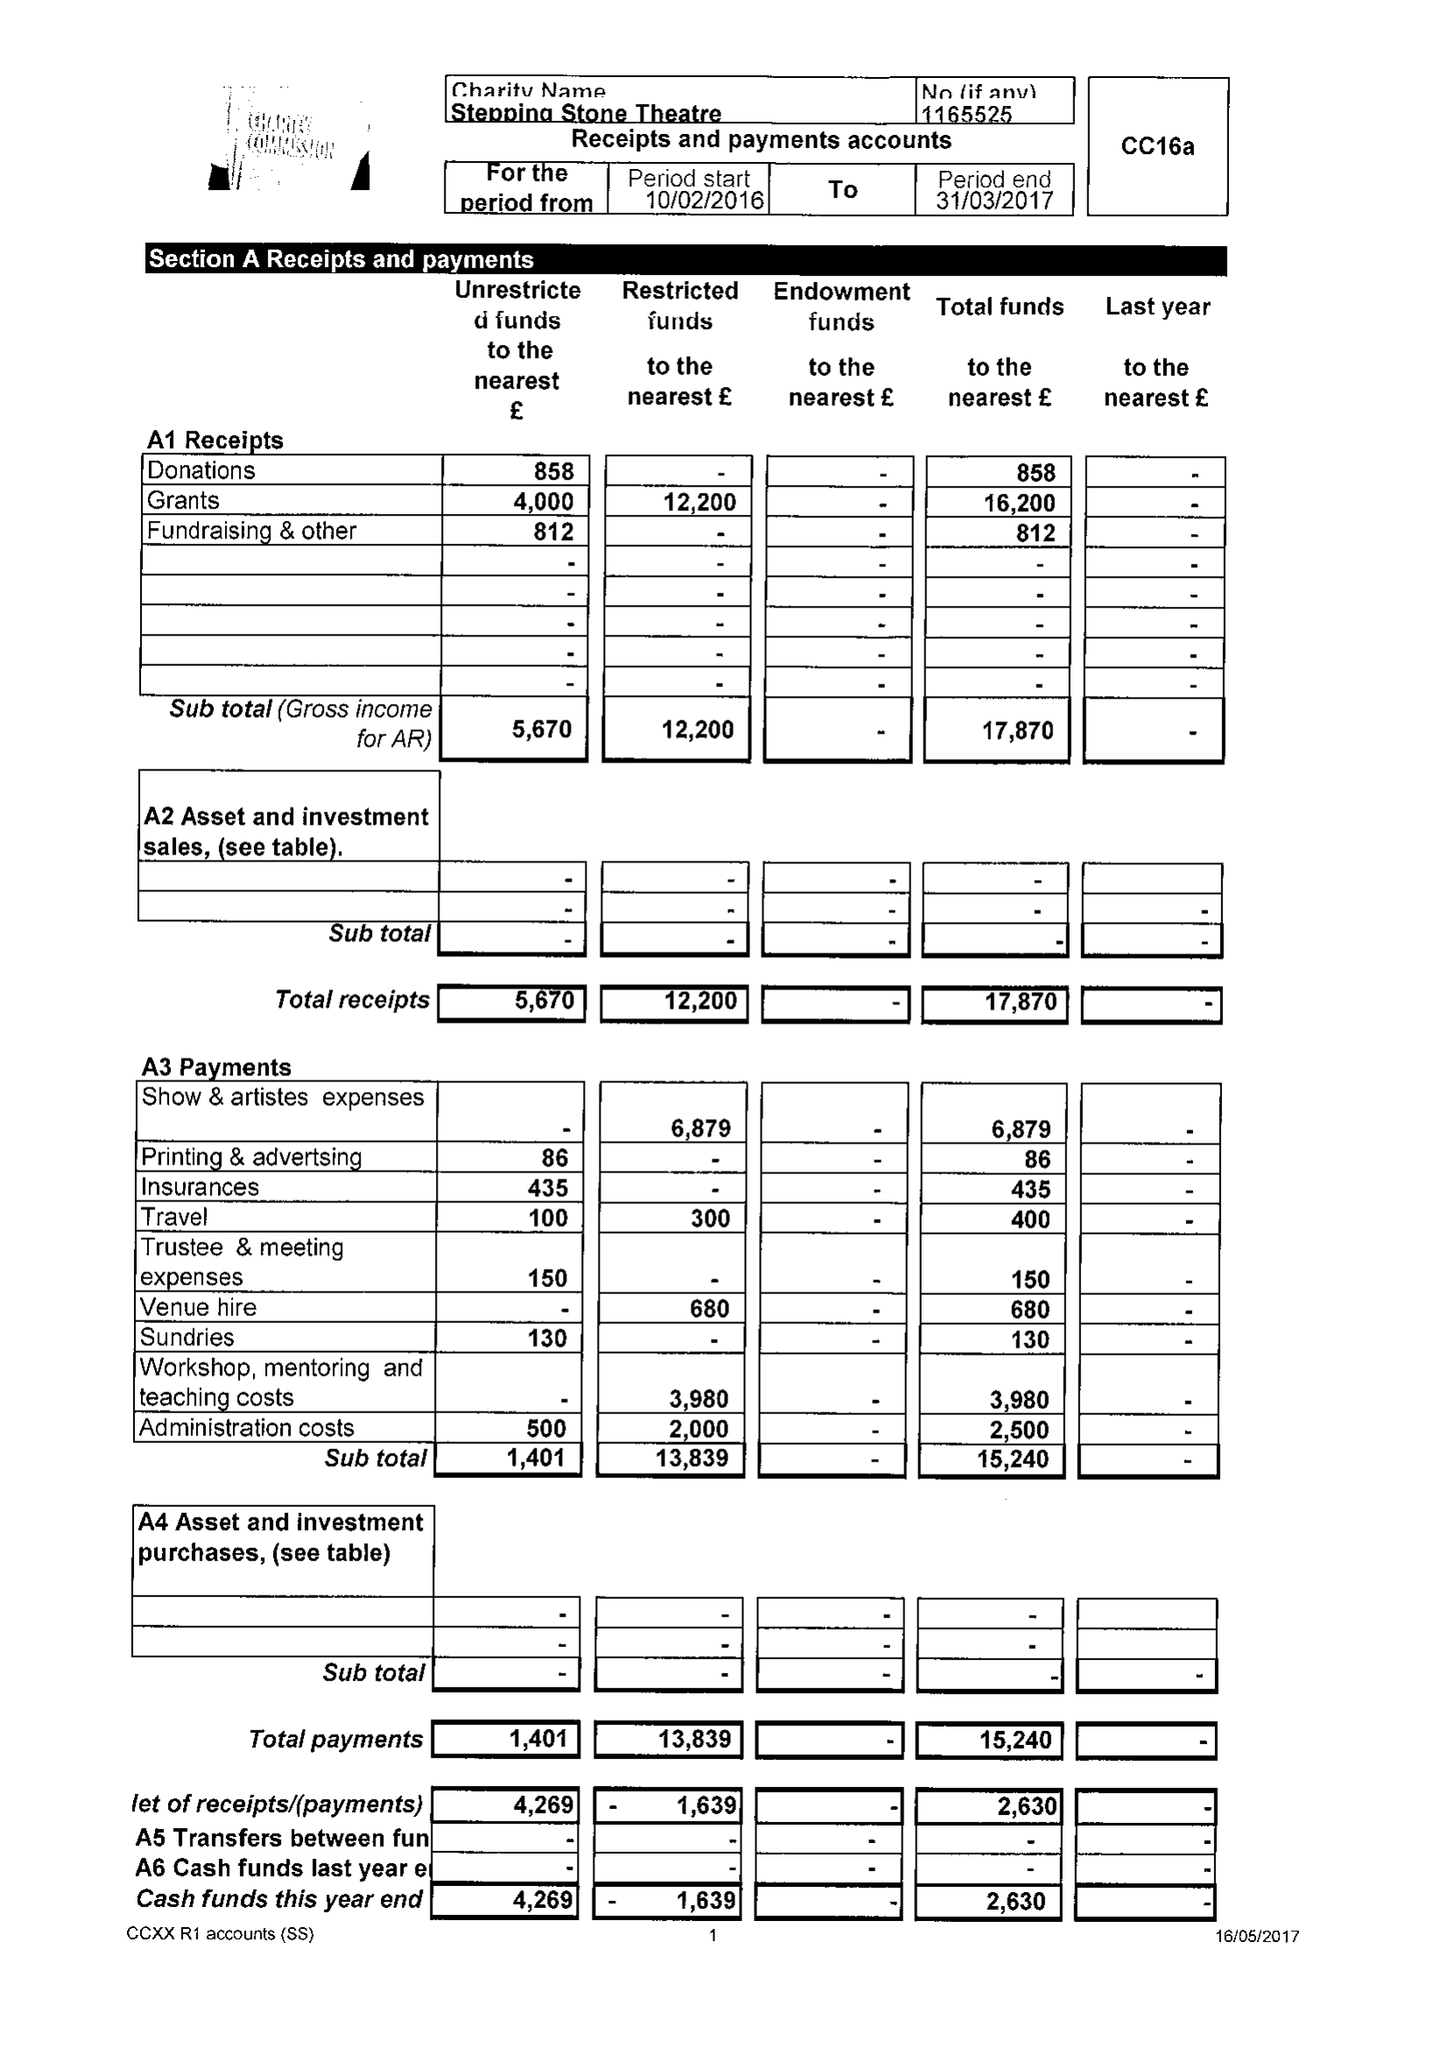What is the value for the charity_name?
Answer the question using a single word or phrase. Stepping Stone Theatre 